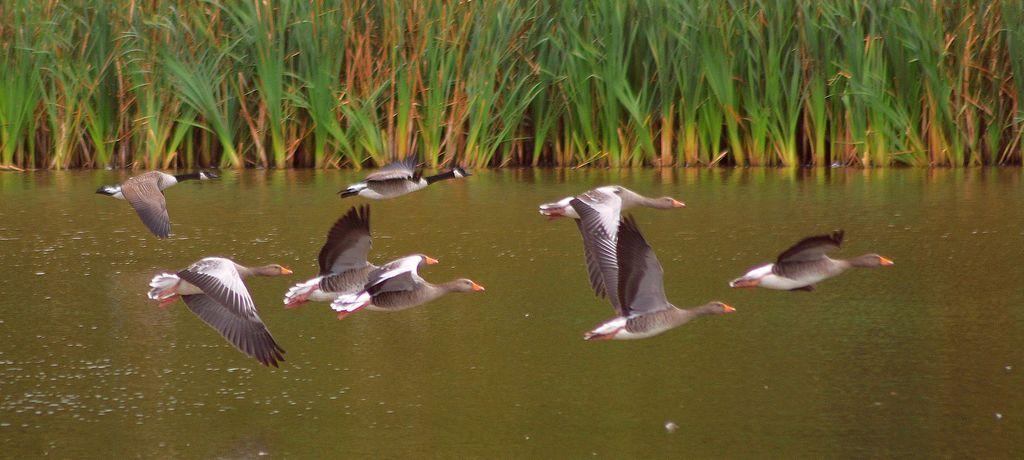What is happening in the image? There are birds flying in the image. What can be seen at the bottom of the image? There is water visible at the bottom of the image. What is visible in the background of the image? There are plants in the background of the image. What type of apparel are the boys wearing in the image? There are no boys present in the image, so it is not possible to determine what type of apparel they might be wearing. 